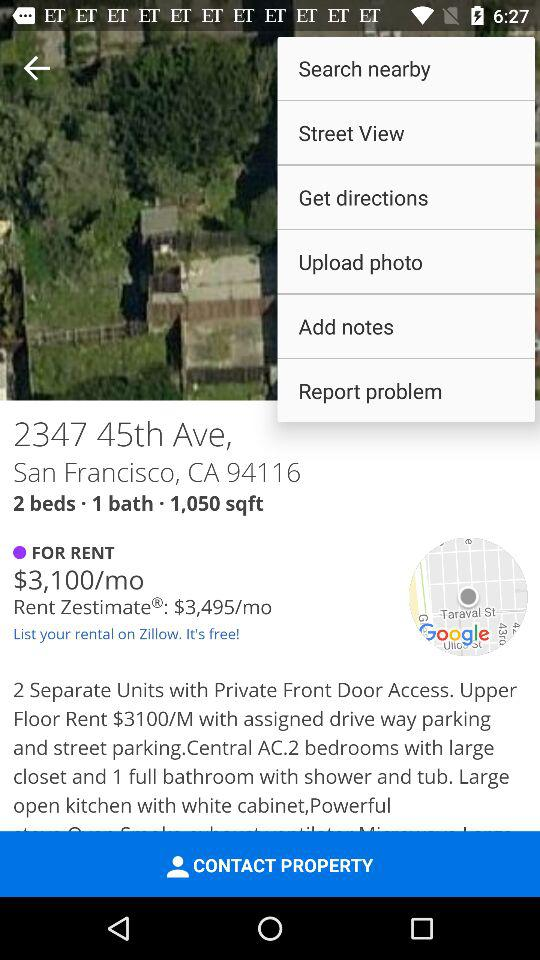How much is the rent? The rent is $3,100/mo. 